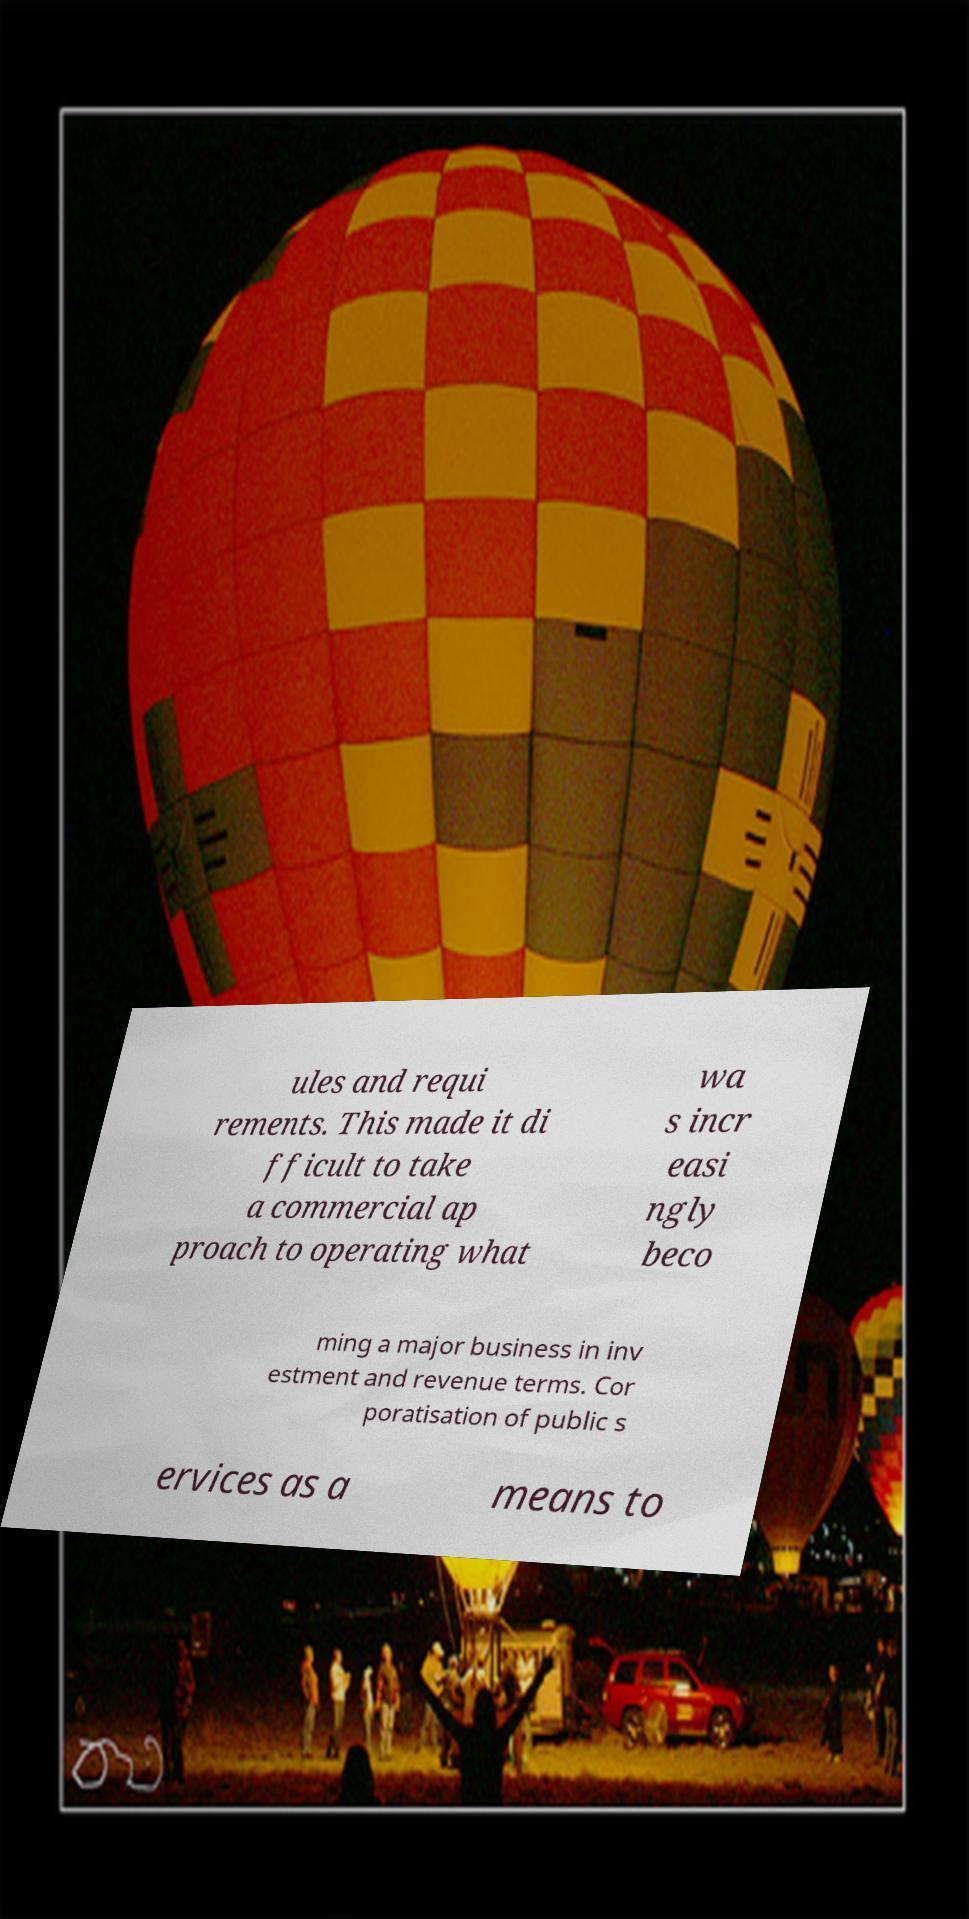Can you read and provide the text displayed in the image?This photo seems to have some interesting text. Can you extract and type it out for me? ules and requi rements. This made it di fficult to take a commercial ap proach to operating what wa s incr easi ngly beco ming a major business in inv estment and revenue terms. Cor poratisation of public s ervices as a means to 